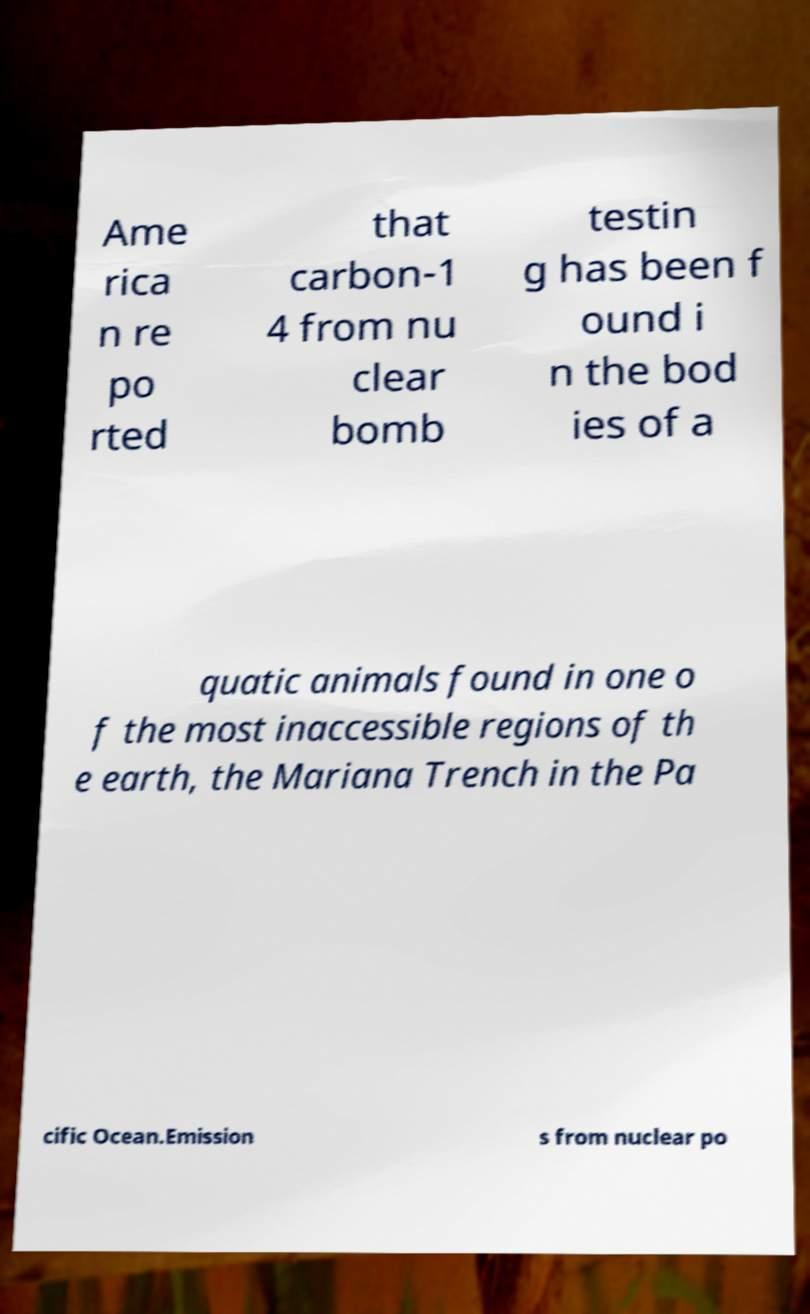Can you accurately transcribe the text from the provided image for me? Ame rica n re po rted that carbon-1 4 from nu clear bomb testin g has been f ound i n the bod ies of a quatic animals found in one o f the most inaccessible regions of th e earth, the Mariana Trench in the Pa cific Ocean.Emission s from nuclear po 